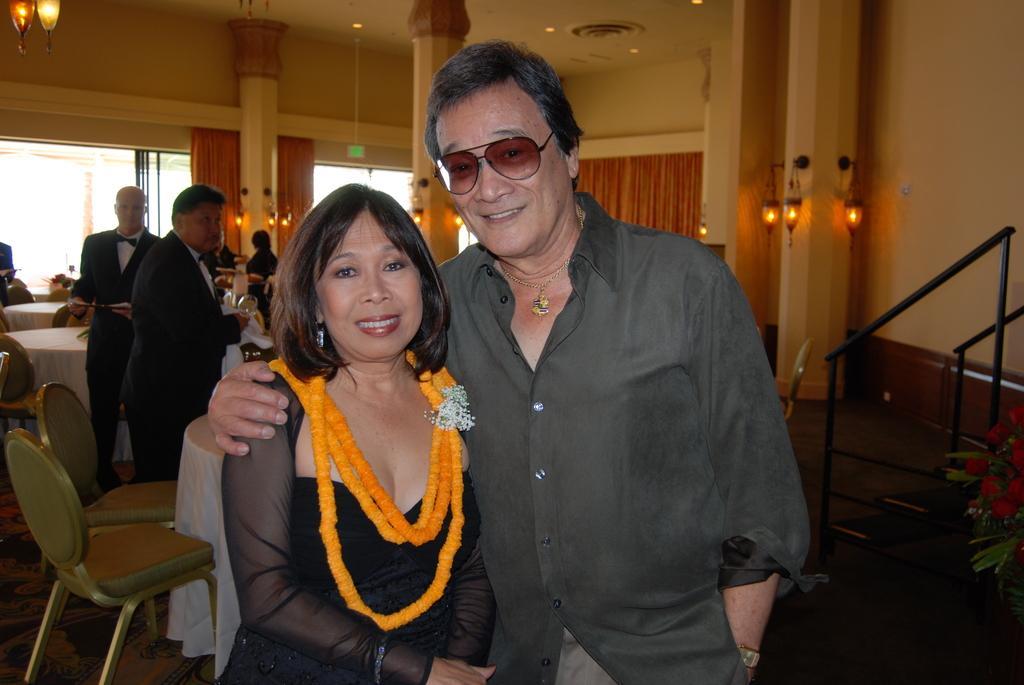Please provide a concise description of this image. In this image there are two people standing and smiling. On the left side there is one woman, on the right side there is one man who is wearing spectacles. On the background of the left top corner there are two lights and on the right side there is one flower pot and some stairs. On the left side there are two tables and chairs. On the left side there are two men standing. On the background of the image there are two curtains and two windows and one ceiling. 